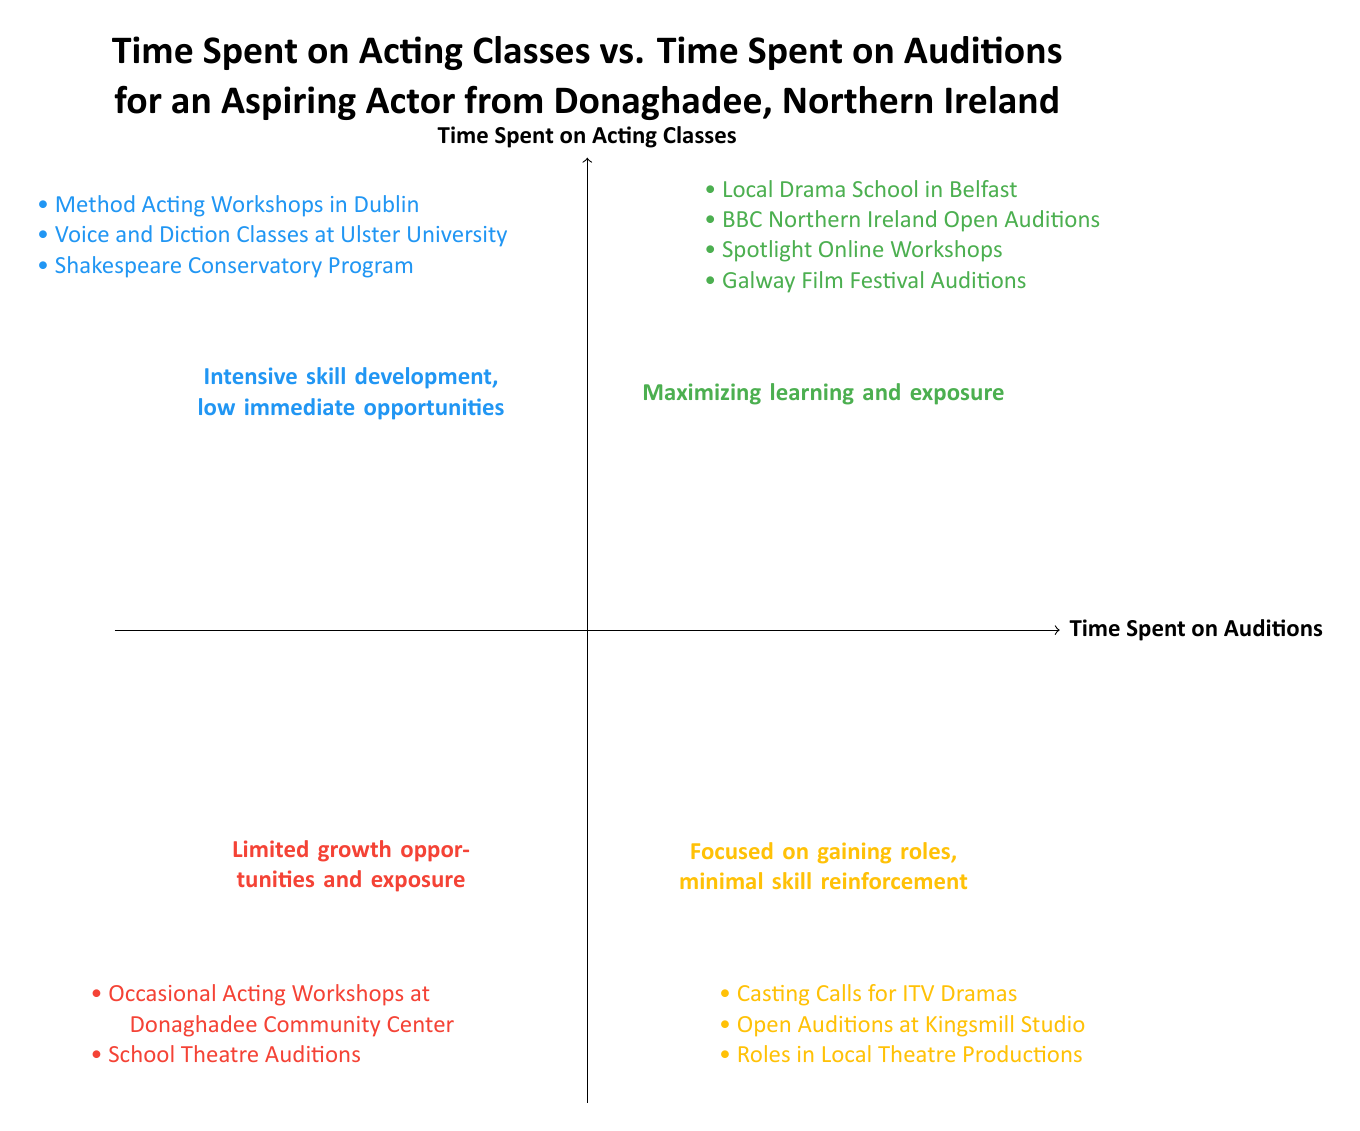What description corresponds to the quadrant with High Acting Classes & High Auditions? The quadrant with High Acting Classes & High Auditions is described as "Maximizing learning and exposure." This is directly stated in the visual information of the quadrant chart.
Answer: Maximizing learning and exposure How many examples of auditions are listed in the Low Acting Classes & High Auditions quadrant? In the Low Acting Classes & High Auditions quadrant, there are three examples of auditions provided: "Casting Calls for ITV Dramas," "Open Auditions at Kingsmill Studio," and "Roles in Local Theatre Productions." By counting these, we find there are three examples.
Answer: 3 What type of opportunities does the High Acting Classes & Low Auditions quadrant provide? The High Acting Classes & Low Auditions quadrant is described as providing "Intensive skill development, low immediate opportunities." This indicates that while skill development is emphasized, there are limited immediate chances for auditions.
Answer: Intensive skill development, low immediate opportunities Which quadrant contains the "Occasional Acting Workshops at Donaghadee Community Center"? The "Occasional Acting Workshops at Donaghadee Community Center" is listed in the Low Acting Classes & Low Auditions quadrant. This can be identified from the examples provided under that specific quadrant label.
Answer: Low Acting Classes & Low Auditions What is the overall focus of the Low Acting Classes & High Auditions quadrant? The Low Acting Classes & High Auditions quadrant focuses on "Gaining roles, minimal skill reinforcement." This is clearly stated in the description of that quadrant in the diagram, indicating a focus on auditions rather than on developing acting skills.
Answer: Gaining roles, minimal skill reinforcement Which quadrant has examples related to the BBC Northern Ireland? The quadrant that includes examples related to the BBC Northern Ireland is the High Acting Classes & High Auditions quadrant, which lists the "BBC Northern Ireland Open Auditions" as one of its examples.
Answer: High Acting Classes & High Auditions How many examples are shown in the High Acting Classes & Low Auditions quadrant? The High Acting Classes & Low Auditions quadrant contains three examples: "Method Acting Workshops in Dublin," "Voice and Diction Classes at Ulster University," and "Shakespeare Conservatory Program." Counting these gives a total of three examples.
Answer: 3 